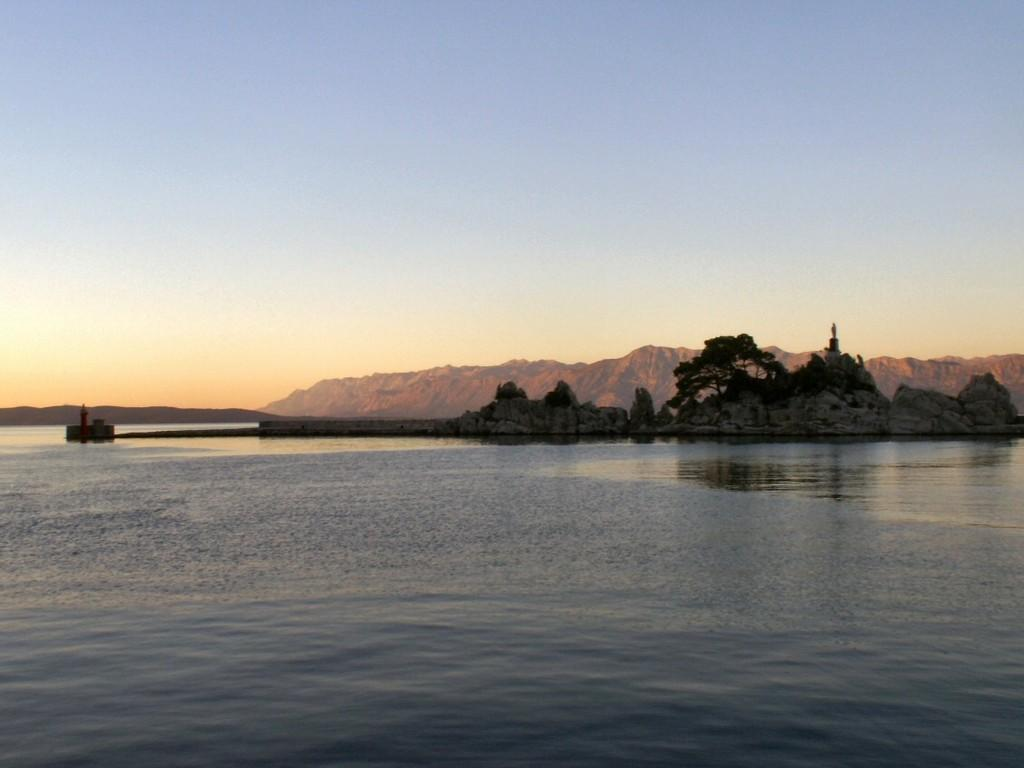What type of natural features can be seen in the image? There are trees, mountains, and rocks visible in the image. What body of water can be seen in the image? There is water visible in the image. How would you describe the sky in the image? The sky is a combination of white, blue, and orange colors. Is there a scarecrow standing among the trees in the image? There is no scarecrow present in the image; it features trees, mountains, rocks, water, and a sky with white, blue, and orange colors. Can you see any volcanic activity in the image? There is no volcanic activity or volcano present in the image. 